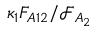Convert formula to latex. <formula><loc_0><loc_0><loc_500><loc_500>\kappa _ { 1 } F _ { A 1 2 } / \mathcal { F } _ { A _ { 2 } }</formula> 